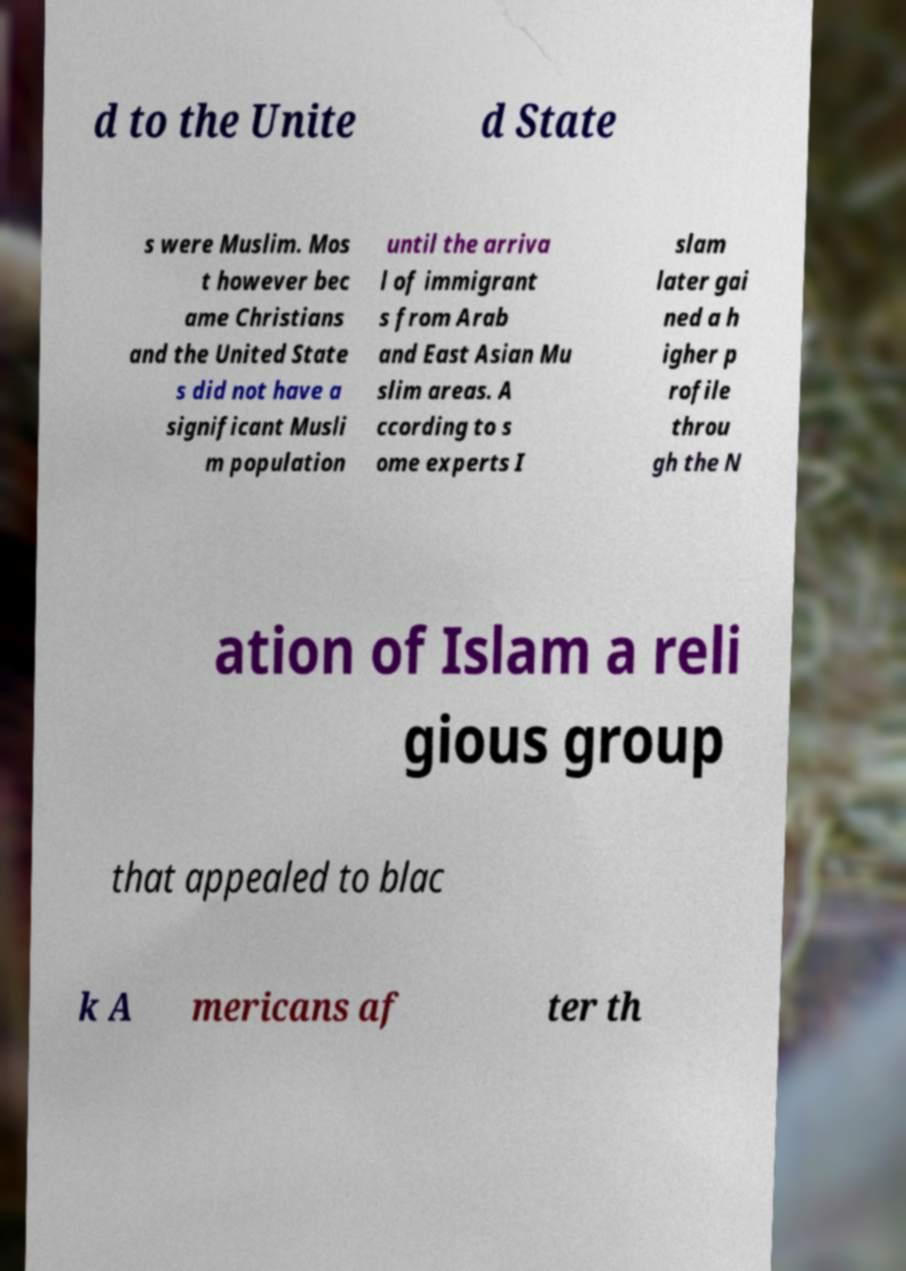What messages or text are displayed in this image? I need them in a readable, typed format. d to the Unite d State s were Muslim. Mos t however bec ame Christians and the United State s did not have a significant Musli m population until the arriva l of immigrant s from Arab and East Asian Mu slim areas. A ccording to s ome experts I slam later gai ned a h igher p rofile throu gh the N ation of Islam a reli gious group that appealed to blac k A mericans af ter th 